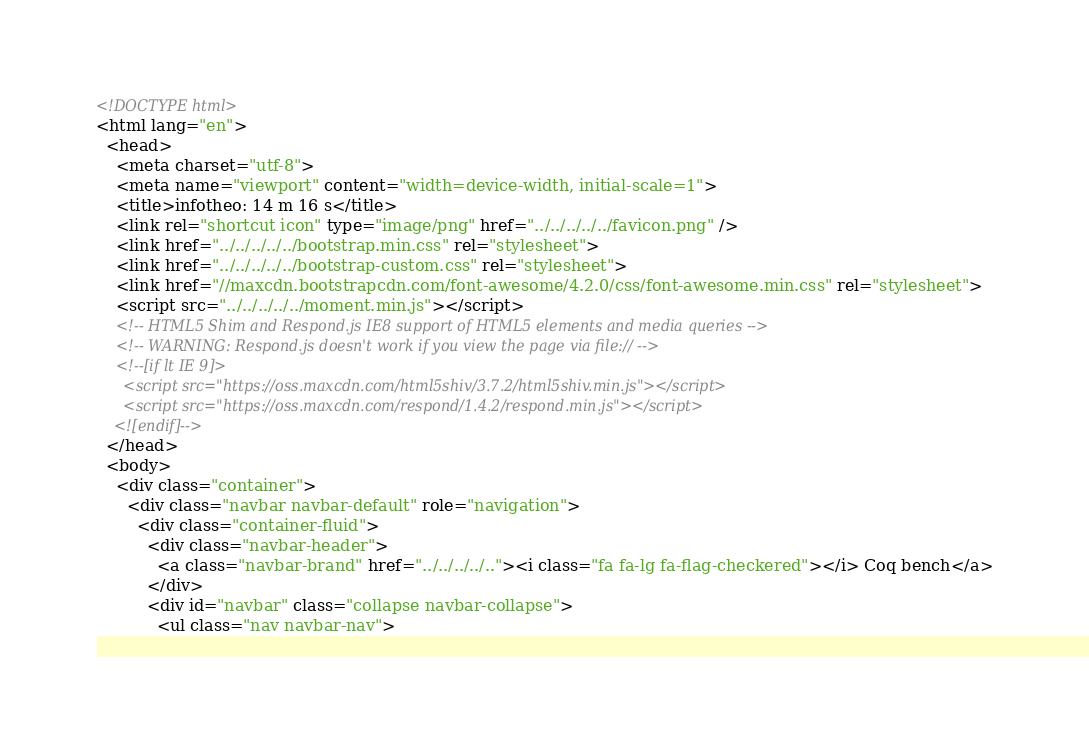Convert code to text. <code><loc_0><loc_0><loc_500><loc_500><_HTML_><!DOCTYPE html>
<html lang="en">
  <head>
    <meta charset="utf-8">
    <meta name="viewport" content="width=device-width, initial-scale=1">
    <title>infotheo: 14 m 16 s</title>
    <link rel="shortcut icon" type="image/png" href="../../../../../favicon.png" />
    <link href="../../../../../bootstrap.min.css" rel="stylesheet">
    <link href="../../../../../bootstrap-custom.css" rel="stylesheet">
    <link href="//maxcdn.bootstrapcdn.com/font-awesome/4.2.0/css/font-awesome.min.css" rel="stylesheet">
    <script src="../../../../../moment.min.js"></script>
    <!-- HTML5 Shim and Respond.js IE8 support of HTML5 elements and media queries -->
    <!-- WARNING: Respond.js doesn't work if you view the page via file:// -->
    <!--[if lt IE 9]>
      <script src="https://oss.maxcdn.com/html5shiv/3.7.2/html5shiv.min.js"></script>
      <script src="https://oss.maxcdn.com/respond/1.4.2/respond.min.js"></script>
    <![endif]-->
  </head>
  <body>
    <div class="container">
      <div class="navbar navbar-default" role="navigation">
        <div class="container-fluid">
          <div class="navbar-header">
            <a class="navbar-brand" href="../../../../.."><i class="fa fa-lg fa-flag-checkered"></i> Coq bench</a>
          </div>
          <div id="navbar" class="collapse navbar-collapse">
            <ul class="nav navbar-nav"></code> 